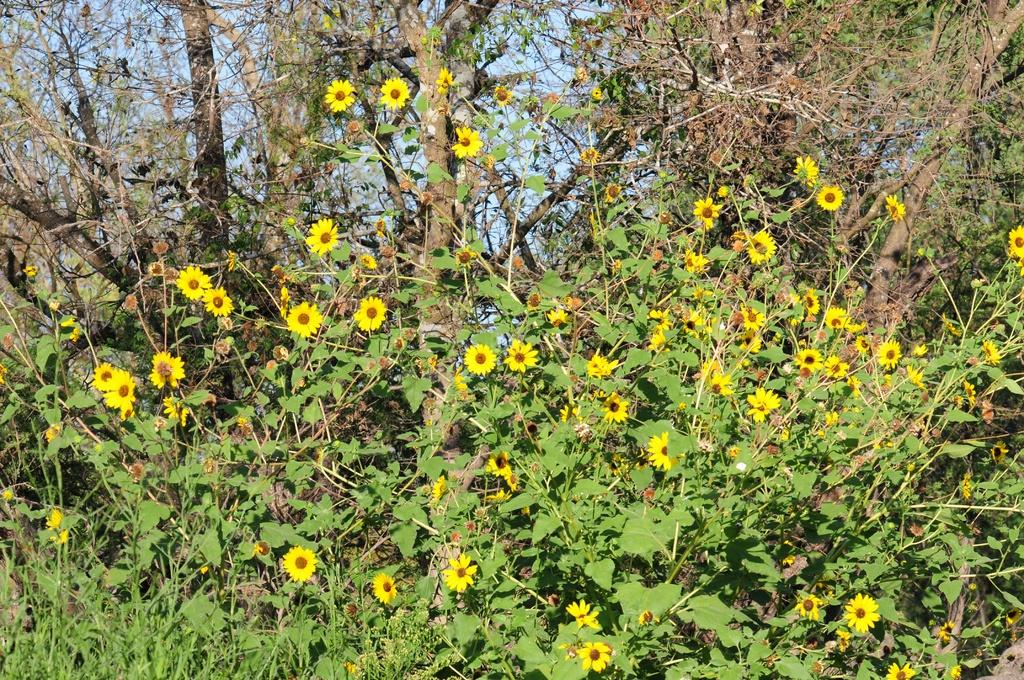What type of living organisms can be seen in the image? There are flowers in the image. What are the flowers growing on? The flowers are on plants. What colors are the flowers? The flowers are in yellow and red colors. What can be seen in the background of the image? There is a sky visible in the background of the image. What type of paint is being used to create the flowers in the image? There is no paint present in the image; the flowers are real and growing on plants. 